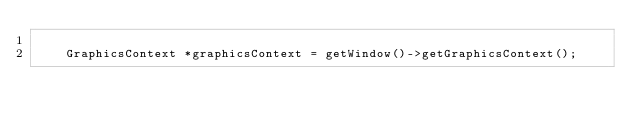<code> <loc_0><loc_0><loc_500><loc_500><_C++_>
		GraphicsContext *graphicsContext = getWindow()->getGraphicsContext();</code> 